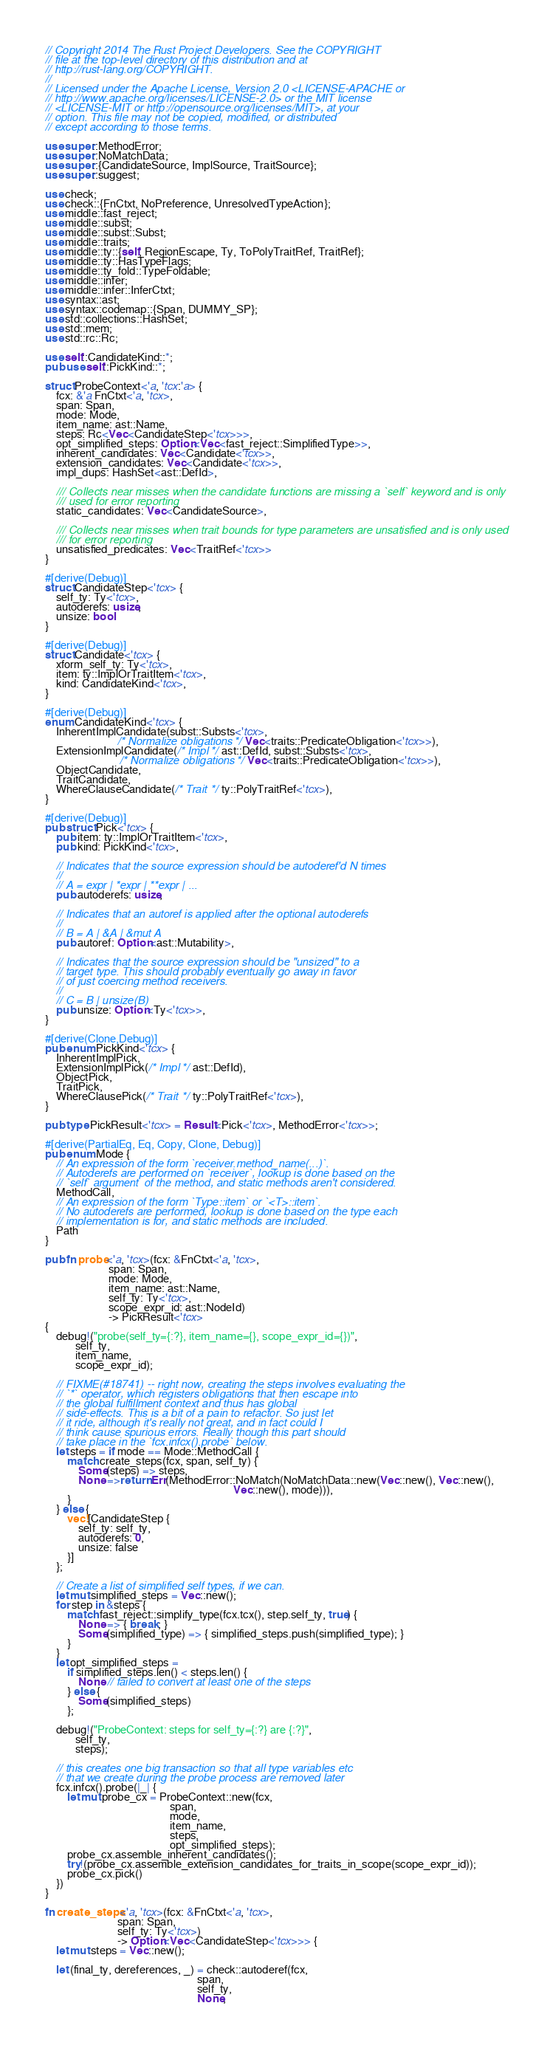<code> <loc_0><loc_0><loc_500><loc_500><_Rust_>// Copyright 2014 The Rust Project Developers. See the COPYRIGHT
// file at the top-level directory of this distribution and at
// http://rust-lang.org/COPYRIGHT.
//
// Licensed under the Apache License, Version 2.0 <LICENSE-APACHE or
// http://www.apache.org/licenses/LICENSE-2.0> or the MIT license
// <LICENSE-MIT or http://opensource.org/licenses/MIT>, at your
// option. This file may not be copied, modified, or distributed
// except according to those terms.

use super::MethodError;
use super::NoMatchData;
use super::{CandidateSource, ImplSource, TraitSource};
use super::suggest;

use check;
use check::{FnCtxt, NoPreference, UnresolvedTypeAction};
use middle::fast_reject;
use middle::subst;
use middle::subst::Subst;
use middle::traits;
use middle::ty::{self, RegionEscape, Ty, ToPolyTraitRef, TraitRef};
use middle::ty::HasTypeFlags;
use middle::ty_fold::TypeFoldable;
use middle::infer;
use middle::infer::InferCtxt;
use syntax::ast;
use syntax::codemap::{Span, DUMMY_SP};
use std::collections::HashSet;
use std::mem;
use std::rc::Rc;

use self::CandidateKind::*;
pub use self::PickKind::*;

struct ProbeContext<'a, 'tcx:'a> {
    fcx: &'a FnCtxt<'a, 'tcx>,
    span: Span,
    mode: Mode,
    item_name: ast::Name,
    steps: Rc<Vec<CandidateStep<'tcx>>>,
    opt_simplified_steps: Option<Vec<fast_reject::SimplifiedType>>,
    inherent_candidates: Vec<Candidate<'tcx>>,
    extension_candidates: Vec<Candidate<'tcx>>,
    impl_dups: HashSet<ast::DefId>,

    /// Collects near misses when the candidate functions are missing a `self` keyword and is only
    /// used for error reporting
    static_candidates: Vec<CandidateSource>,

    /// Collects near misses when trait bounds for type parameters are unsatisfied and is only used
    /// for error reporting
    unsatisfied_predicates: Vec<TraitRef<'tcx>>
}

#[derive(Debug)]
struct CandidateStep<'tcx> {
    self_ty: Ty<'tcx>,
    autoderefs: usize,
    unsize: bool
}

#[derive(Debug)]
struct Candidate<'tcx> {
    xform_self_ty: Ty<'tcx>,
    item: ty::ImplOrTraitItem<'tcx>,
    kind: CandidateKind<'tcx>,
}

#[derive(Debug)]
enum CandidateKind<'tcx> {
    InherentImplCandidate(subst::Substs<'tcx>,
                          /* Normalize obligations */ Vec<traits::PredicateObligation<'tcx>>),
    ExtensionImplCandidate(/* Impl */ ast::DefId, subst::Substs<'tcx>,
                           /* Normalize obligations */ Vec<traits::PredicateObligation<'tcx>>),
    ObjectCandidate,
    TraitCandidate,
    WhereClauseCandidate(/* Trait */ ty::PolyTraitRef<'tcx>),
}

#[derive(Debug)]
pub struct Pick<'tcx> {
    pub item: ty::ImplOrTraitItem<'tcx>,
    pub kind: PickKind<'tcx>,

    // Indicates that the source expression should be autoderef'd N times
    //
    // A = expr | *expr | **expr | ...
    pub autoderefs: usize,

    // Indicates that an autoref is applied after the optional autoderefs
    //
    // B = A | &A | &mut A
    pub autoref: Option<ast::Mutability>,

    // Indicates that the source expression should be "unsized" to a
    // target type. This should probably eventually go away in favor
    // of just coercing method receivers.
    //
    // C = B | unsize(B)
    pub unsize: Option<Ty<'tcx>>,
}

#[derive(Clone,Debug)]
pub enum PickKind<'tcx> {
    InherentImplPick,
    ExtensionImplPick(/* Impl */ ast::DefId),
    ObjectPick,
    TraitPick,
    WhereClausePick(/* Trait */ ty::PolyTraitRef<'tcx>),
}

pub type PickResult<'tcx> = Result<Pick<'tcx>, MethodError<'tcx>>;

#[derive(PartialEq, Eq, Copy, Clone, Debug)]
pub enum Mode {
    // An expression of the form `receiver.method_name(...)`.
    // Autoderefs are performed on `receiver`, lookup is done based on the
    // `self` argument  of the method, and static methods aren't considered.
    MethodCall,
    // An expression of the form `Type::item` or `<T>::item`.
    // No autoderefs are performed, lookup is done based on the type each
    // implementation is for, and static methods are included.
    Path
}

pub fn probe<'a, 'tcx>(fcx: &FnCtxt<'a, 'tcx>,
                       span: Span,
                       mode: Mode,
                       item_name: ast::Name,
                       self_ty: Ty<'tcx>,
                       scope_expr_id: ast::NodeId)
                       -> PickResult<'tcx>
{
    debug!("probe(self_ty={:?}, item_name={}, scope_expr_id={})",
           self_ty,
           item_name,
           scope_expr_id);

    // FIXME(#18741) -- right now, creating the steps involves evaluating the
    // `*` operator, which registers obligations that then escape into
    // the global fulfillment context and thus has global
    // side-effects. This is a bit of a pain to refactor. So just let
    // it ride, although it's really not great, and in fact could I
    // think cause spurious errors. Really though this part should
    // take place in the `fcx.infcx().probe` below.
    let steps = if mode == Mode::MethodCall {
        match create_steps(fcx, span, self_ty) {
            Some(steps) => steps,
            None =>return Err(MethodError::NoMatch(NoMatchData::new(Vec::new(), Vec::new(),
                                                                    Vec::new(), mode))),
        }
    } else {
        vec![CandidateStep {
            self_ty: self_ty,
            autoderefs: 0,
            unsize: false
        }]
    };

    // Create a list of simplified self types, if we can.
    let mut simplified_steps = Vec::new();
    for step in &steps {
        match fast_reject::simplify_type(fcx.tcx(), step.self_ty, true) {
            None => { break; }
            Some(simplified_type) => { simplified_steps.push(simplified_type); }
        }
    }
    let opt_simplified_steps =
        if simplified_steps.len() < steps.len() {
            None // failed to convert at least one of the steps
        } else {
            Some(simplified_steps)
        };

    debug!("ProbeContext: steps for self_ty={:?} are {:?}",
           self_ty,
           steps);

    // this creates one big transaction so that all type variables etc
    // that we create during the probe process are removed later
    fcx.infcx().probe(|_| {
        let mut probe_cx = ProbeContext::new(fcx,
                                             span,
                                             mode,
                                             item_name,
                                             steps,
                                             opt_simplified_steps);
        probe_cx.assemble_inherent_candidates();
        try!(probe_cx.assemble_extension_candidates_for_traits_in_scope(scope_expr_id));
        probe_cx.pick()
    })
}

fn create_steps<'a, 'tcx>(fcx: &FnCtxt<'a, 'tcx>,
                          span: Span,
                          self_ty: Ty<'tcx>)
                          -> Option<Vec<CandidateStep<'tcx>>> {
    let mut steps = Vec::new();

    let (final_ty, dereferences, _) = check::autoderef(fcx,
                                                       span,
                                                       self_ty,
                                                       None,</code> 